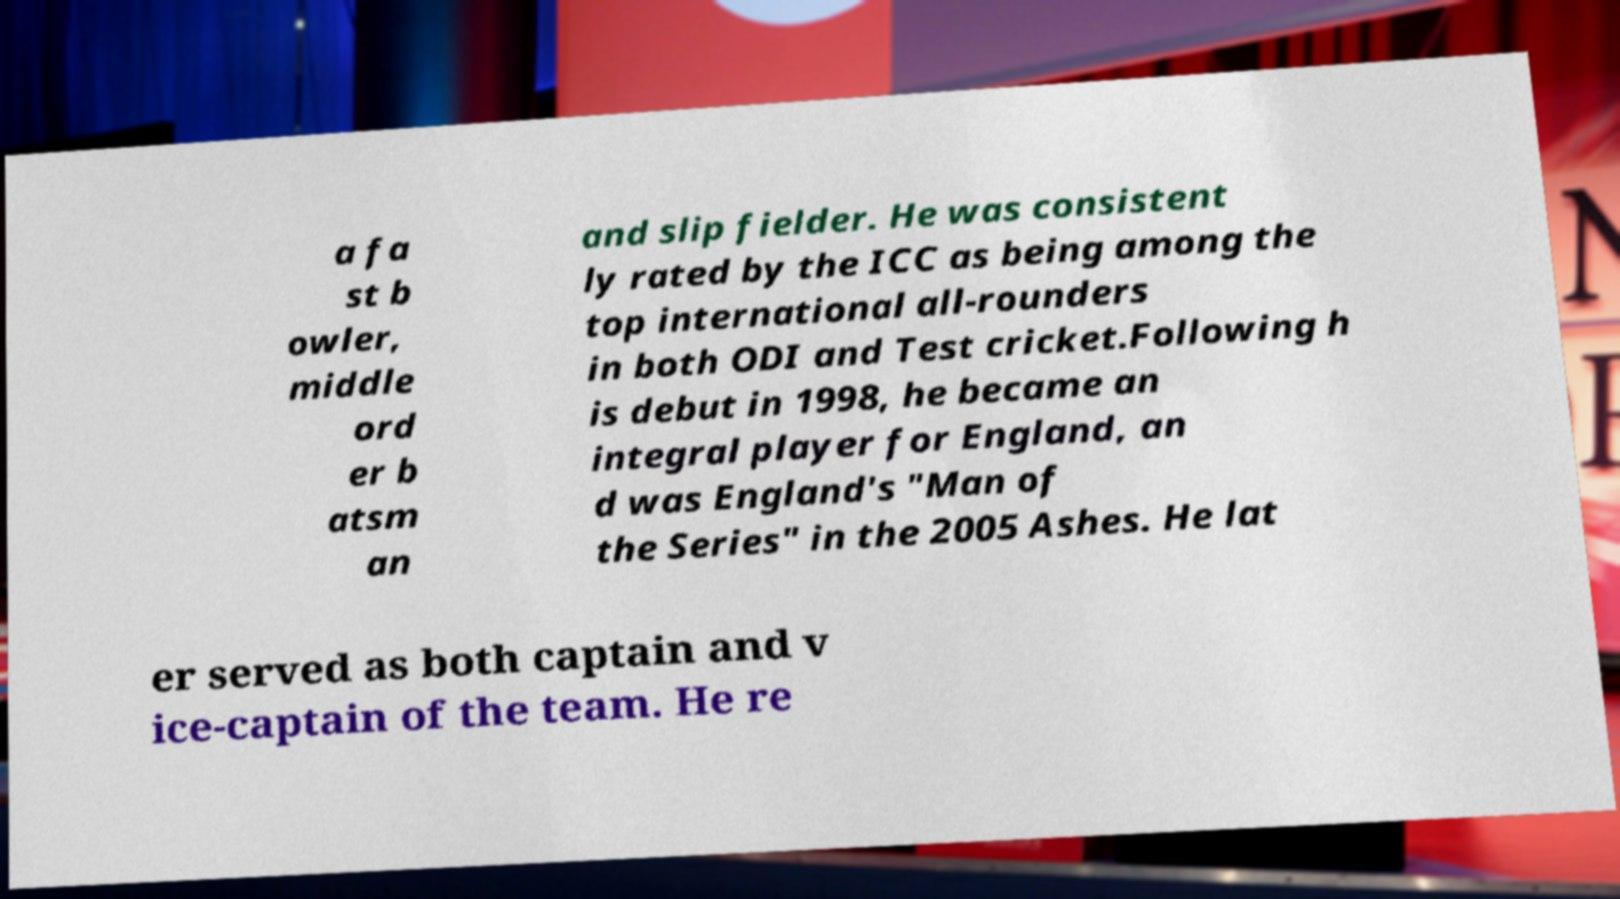What messages or text are displayed in this image? I need them in a readable, typed format. a fa st b owler, middle ord er b atsm an and slip fielder. He was consistent ly rated by the ICC as being among the top international all-rounders in both ODI and Test cricket.Following h is debut in 1998, he became an integral player for England, an d was England's "Man of the Series" in the 2005 Ashes. He lat er served as both captain and v ice-captain of the team. He re 